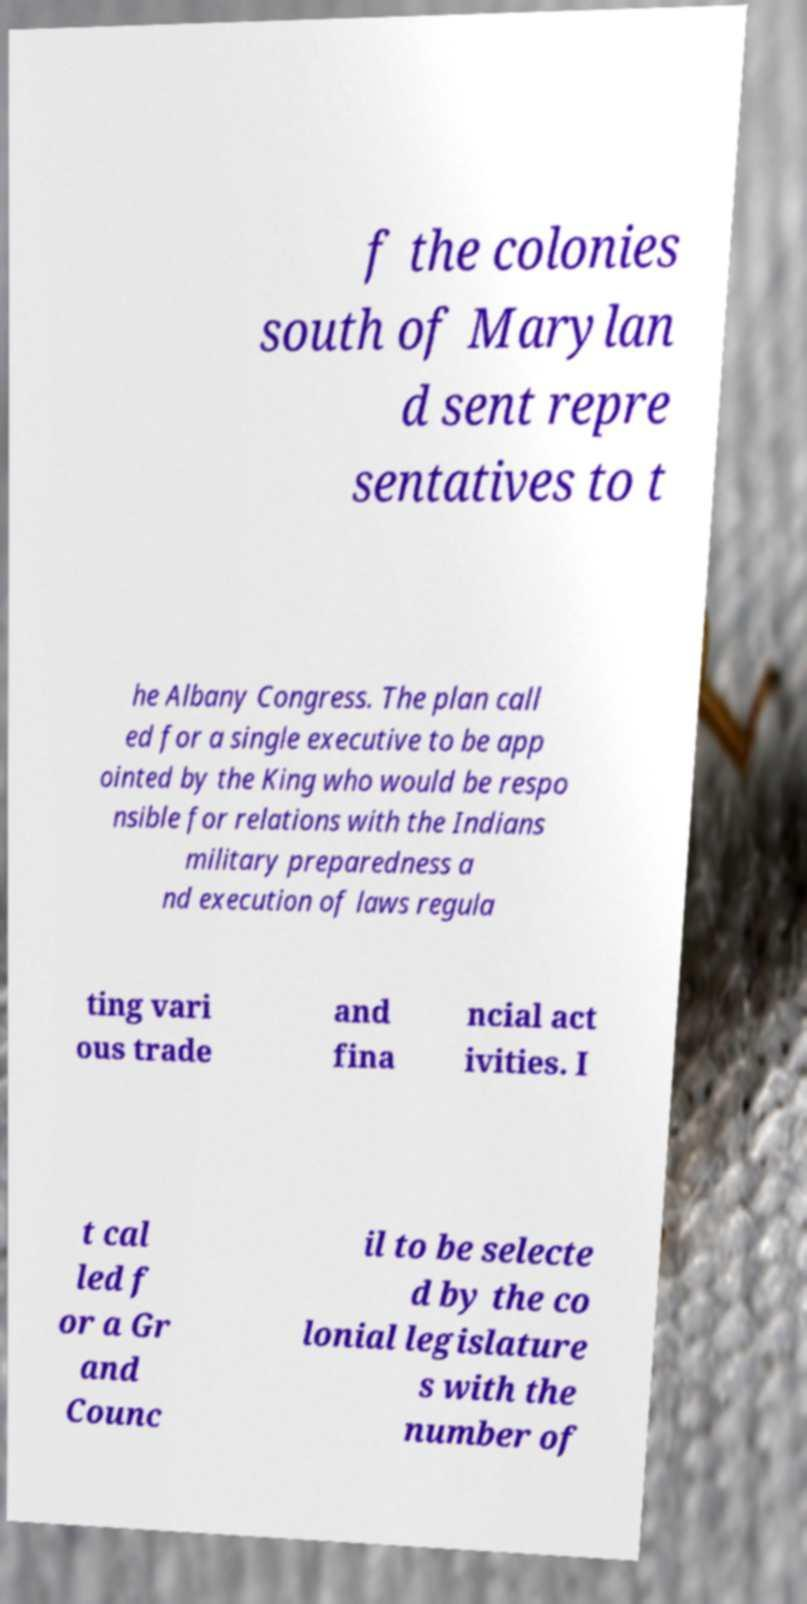Please identify and transcribe the text found in this image. f the colonies south of Marylan d sent repre sentatives to t he Albany Congress. The plan call ed for a single executive to be app ointed by the King who would be respo nsible for relations with the Indians military preparedness a nd execution of laws regula ting vari ous trade and fina ncial act ivities. I t cal led f or a Gr and Counc il to be selecte d by the co lonial legislature s with the number of 